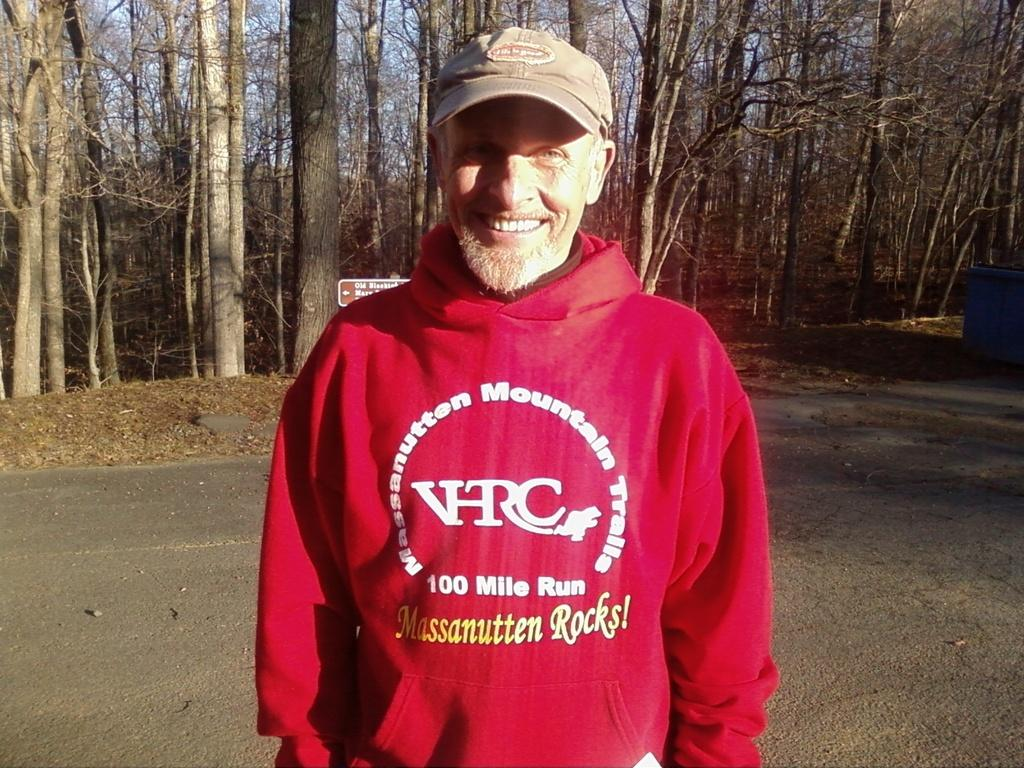<image>
Give a short and clear explanation of the subsequent image. The sweat shirt is for a one hundred mile run 